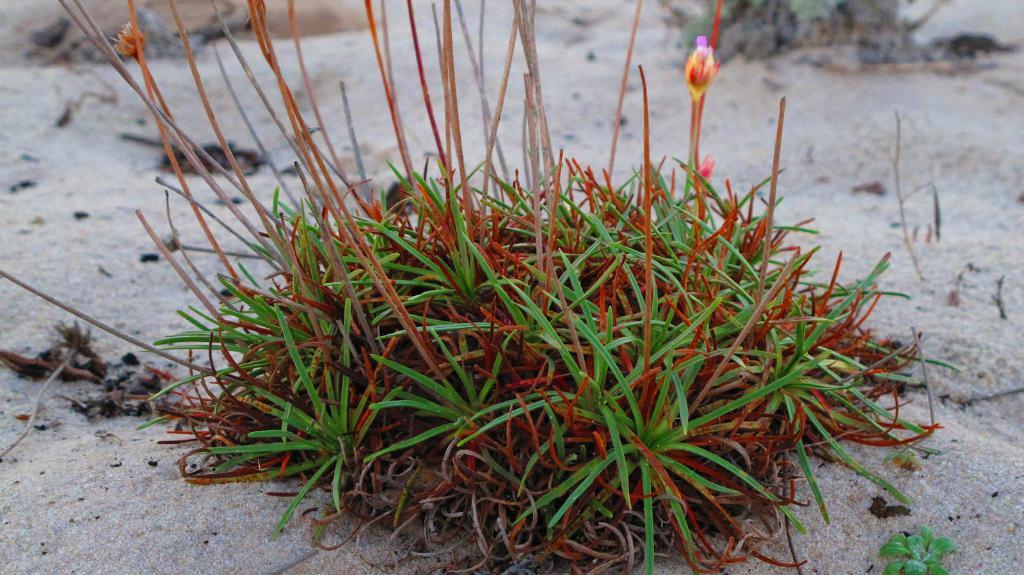What type of vegetation can be seen in the image? There is grass and a plant with flowers in the image. What is the texture of the ground in the image? There is sand on the ground in the image. What type of hat is the salt wearing in the image? There is no salt or hat present in the image. 